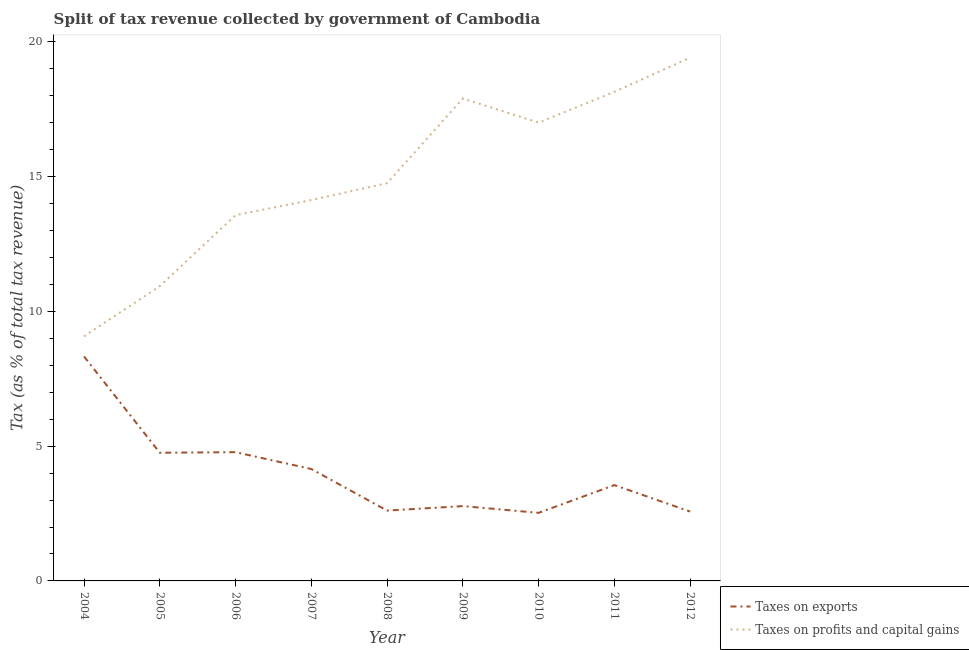How many different coloured lines are there?
Your answer should be compact. 2. Does the line corresponding to percentage of revenue obtained from taxes on profits and capital gains intersect with the line corresponding to percentage of revenue obtained from taxes on exports?
Offer a very short reply. No. What is the percentage of revenue obtained from taxes on profits and capital gains in 2007?
Your answer should be compact. 14.13. Across all years, what is the maximum percentage of revenue obtained from taxes on exports?
Make the answer very short. 8.33. Across all years, what is the minimum percentage of revenue obtained from taxes on profits and capital gains?
Give a very brief answer. 9.07. What is the total percentage of revenue obtained from taxes on profits and capital gains in the graph?
Offer a terse response. 134.96. What is the difference between the percentage of revenue obtained from taxes on profits and capital gains in 2011 and that in 2012?
Offer a very short reply. -1.27. What is the difference between the percentage of revenue obtained from taxes on exports in 2005 and the percentage of revenue obtained from taxes on profits and capital gains in 2012?
Offer a terse response. -14.66. What is the average percentage of revenue obtained from taxes on exports per year?
Give a very brief answer. 4.01. In the year 2010, what is the difference between the percentage of revenue obtained from taxes on exports and percentage of revenue obtained from taxes on profits and capital gains?
Offer a very short reply. -14.48. In how many years, is the percentage of revenue obtained from taxes on exports greater than 7 %?
Ensure brevity in your answer.  1. What is the ratio of the percentage of revenue obtained from taxes on exports in 2004 to that in 2011?
Your answer should be very brief. 2.34. Is the difference between the percentage of revenue obtained from taxes on profits and capital gains in 2009 and 2010 greater than the difference between the percentage of revenue obtained from taxes on exports in 2009 and 2010?
Ensure brevity in your answer.  Yes. What is the difference between the highest and the second highest percentage of revenue obtained from taxes on profits and capital gains?
Offer a terse response. 1.27. What is the difference between the highest and the lowest percentage of revenue obtained from taxes on profits and capital gains?
Make the answer very short. 10.34. In how many years, is the percentage of revenue obtained from taxes on profits and capital gains greater than the average percentage of revenue obtained from taxes on profits and capital gains taken over all years?
Ensure brevity in your answer.  4. Is the sum of the percentage of revenue obtained from taxes on profits and capital gains in 2005 and 2008 greater than the maximum percentage of revenue obtained from taxes on exports across all years?
Keep it short and to the point. Yes. Is the percentage of revenue obtained from taxes on profits and capital gains strictly greater than the percentage of revenue obtained from taxes on exports over the years?
Give a very brief answer. Yes. How many lines are there?
Give a very brief answer. 2. What is the difference between two consecutive major ticks on the Y-axis?
Keep it short and to the point. 5. Are the values on the major ticks of Y-axis written in scientific E-notation?
Keep it short and to the point. No. What is the title of the graph?
Your answer should be very brief. Split of tax revenue collected by government of Cambodia. Does "GDP at market prices" appear as one of the legend labels in the graph?
Give a very brief answer. No. What is the label or title of the X-axis?
Your answer should be very brief. Year. What is the label or title of the Y-axis?
Offer a terse response. Tax (as % of total tax revenue). What is the Tax (as % of total tax revenue) of Taxes on exports in 2004?
Your answer should be compact. 8.33. What is the Tax (as % of total tax revenue) of Taxes on profits and capital gains in 2004?
Your answer should be very brief. 9.07. What is the Tax (as % of total tax revenue) of Taxes on exports in 2005?
Offer a terse response. 4.76. What is the Tax (as % of total tax revenue) in Taxes on profits and capital gains in 2005?
Your answer should be very brief. 10.94. What is the Tax (as % of total tax revenue) in Taxes on exports in 2006?
Your answer should be very brief. 4.78. What is the Tax (as % of total tax revenue) in Taxes on profits and capital gains in 2006?
Offer a terse response. 13.57. What is the Tax (as % of total tax revenue) in Taxes on exports in 2007?
Give a very brief answer. 4.15. What is the Tax (as % of total tax revenue) in Taxes on profits and capital gains in 2007?
Your answer should be very brief. 14.13. What is the Tax (as % of total tax revenue) in Taxes on exports in 2008?
Your answer should be very brief. 2.61. What is the Tax (as % of total tax revenue) of Taxes on profits and capital gains in 2008?
Provide a short and direct response. 14.76. What is the Tax (as % of total tax revenue) in Taxes on exports in 2009?
Provide a short and direct response. 2.78. What is the Tax (as % of total tax revenue) of Taxes on profits and capital gains in 2009?
Offer a terse response. 17.9. What is the Tax (as % of total tax revenue) in Taxes on exports in 2010?
Provide a succinct answer. 2.53. What is the Tax (as % of total tax revenue) of Taxes on profits and capital gains in 2010?
Your answer should be compact. 17.01. What is the Tax (as % of total tax revenue) of Taxes on exports in 2011?
Provide a succinct answer. 3.56. What is the Tax (as % of total tax revenue) in Taxes on profits and capital gains in 2011?
Offer a very short reply. 18.15. What is the Tax (as % of total tax revenue) of Taxes on exports in 2012?
Your answer should be very brief. 2.57. What is the Tax (as % of total tax revenue) of Taxes on profits and capital gains in 2012?
Give a very brief answer. 19.42. Across all years, what is the maximum Tax (as % of total tax revenue) of Taxes on exports?
Offer a very short reply. 8.33. Across all years, what is the maximum Tax (as % of total tax revenue) in Taxes on profits and capital gains?
Make the answer very short. 19.42. Across all years, what is the minimum Tax (as % of total tax revenue) of Taxes on exports?
Give a very brief answer. 2.53. Across all years, what is the minimum Tax (as % of total tax revenue) of Taxes on profits and capital gains?
Give a very brief answer. 9.07. What is the total Tax (as % of total tax revenue) in Taxes on exports in the graph?
Keep it short and to the point. 36.06. What is the total Tax (as % of total tax revenue) of Taxes on profits and capital gains in the graph?
Give a very brief answer. 134.96. What is the difference between the Tax (as % of total tax revenue) of Taxes on exports in 2004 and that in 2005?
Provide a succinct answer. 3.57. What is the difference between the Tax (as % of total tax revenue) of Taxes on profits and capital gains in 2004 and that in 2005?
Ensure brevity in your answer.  -1.86. What is the difference between the Tax (as % of total tax revenue) in Taxes on exports in 2004 and that in 2006?
Offer a terse response. 3.55. What is the difference between the Tax (as % of total tax revenue) in Taxes on profits and capital gains in 2004 and that in 2006?
Make the answer very short. -4.5. What is the difference between the Tax (as % of total tax revenue) in Taxes on exports in 2004 and that in 2007?
Your response must be concise. 4.18. What is the difference between the Tax (as % of total tax revenue) in Taxes on profits and capital gains in 2004 and that in 2007?
Your response must be concise. -5.06. What is the difference between the Tax (as % of total tax revenue) of Taxes on exports in 2004 and that in 2008?
Give a very brief answer. 5.72. What is the difference between the Tax (as % of total tax revenue) of Taxes on profits and capital gains in 2004 and that in 2008?
Offer a terse response. -5.69. What is the difference between the Tax (as % of total tax revenue) in Taxes on exports in 2004 and that in 2009?
Give a very brief answer. 5.55. What is the difference between the Tax (as % of total tax revenue) of Taxes on profits and capital gains in 2004 and that in 2009?
Your response must be concise. -8.83. What is the difference between the Tax (as % of total tax revenue) in Taxes on exports in 2004 and that in 2010?
Your response must be concise. 5.8. What is the difference between the Tax (as % of total tax revenue) in Taxes on profits and capital gains in 2004 and that in 2010?
Give a very brief answer. -7.93. What is the difference between the Tax (as % of total tax revenue) in Taxes on exports in 2004 and that in 2011?
Your response must be concise. 4.77. What is the difference between the Tax (as % of total tax revenue) in Taxes on profits and capital gains in 2004 and that in 2011?
Your answer should be compact. -9.07. What is the difference between the Tax (as % of total tax revenue) in Taxes on exports in 2004 and that in 2012?
Provide a short and direct response. 5.76. What is the difference between the Tax (as % of total tax revenue) in Taxes on profits and capital gains in 2004 and that in 2012?
Ensure brevity in your answer.  -10.34. What is the difference between the Tax (as % of total tax revenue) in Taxes on exports in 2005 and that in 2006?
Your answer should be compact. -0.02. What is the difference between the Tax (as % of total tax revenue) of Taxes on profits and capital gains in 2005 and that in 2006?
Offer a terse response. -2.63. What is the difference between the Tax (as % of total tax revenue) of Taxes on exports in 2005 and that in 2007?
Give a very brief answer. 0.6. What is the difference between the Tax (as % of total tax revenue) of Taxes on profits and capital gains in 2005 and that in 2007?
Offer a terse response. -3.19. What is the difference between the Tax (as % of total tax revenue) of Taxes on exports in 2005 and that in 2008?
Provide a succinct answer. 2.15. What is the difference between the Tax (as % of total tax revenue) of Taxes on profits and capital gains in 2005 and that in 2008?
Provide a short and direct response. -3.82. What is the difference between the Tax (as % of total tax revenue) of Taxes on exports in 2005 and that in 2009?
Keep it short and to the point. 1.98. What is the difference between the Tax (as % of total tax revenue) in Taxes on profits and capital gains in 2005 and that in 2009?
Offer a very short reply. -6.96. What is the difference between the Tax (as % of total tax revenue) in Taxes on exports in 2005 and that in 2010?
Keep it short and to the point. 2.23. What is the difference between the Tax (as % of total tax revenue) in Taxes on profits and capital gains in 2005 and that in 2010?
Provide a succinct answer. -6.07. What is the difference between the Tax (as % of total tax revenue) in Taxes on exports in 2005 and that in 2011?
Ensure brevity in your answer.  1.2. What is the difference between the Tax (as % of total tax revenue) in Taxes on profits and capital gains in 2005 and that in 2011?
Your answer should be very brief. -7.21. What is the difference between the Tax (as % of total tax revenue) in Taxes on exports in 2005 and that in 2012?
Keep it short and to the point. 2.18. What is the difference between the Tax (as % of total tax revenue) of Taxes on profits and capital gains in 2005 and that in 2012?
Your response must be concise. -8.48. What is the difference between the Tax (as % of total tax revenue) of Taxes on exports in 2006 and that in 2007?
Offer a very short reply. 0.62. What is the difference between the Tax (as % of total tax revenue) in Taxes on profits and capital gains in 2006 and that in 2007?
Your answer should be very brief. -0.56. What is the difference between the Tax (as % of total tax revenue) of Taxes on exports in 2006 and that in 2008?
Give a very brief answer. 2.17. What is the difference between the Tax (as % of total tax revenue) in Taxes on profits and capital gains in 2006 and that in 2008?
Ensure brevity in your answer.  -1.19. What is the difference between the Tax (as % of total tax revenue) of Taxes on exports in 2006 and that in 2009?
Your response must be concise. 2. What is the difference between the Tax (as % of total tax revenue) of Taxes on profits and capital gains in 2006 and that in 2009?
Your response must be concise. -4.33. What is the difference between the Tax (as % of total tax revenue) in Taxes on exports in 2006 and that in 2010?
Offer a terse response. 2.25. What is the difference between the Tax (as % of total tax revenue) of Taxes on profits and capital gains in 2006 and that in 2010?
Your answer should be very brief. -3.43. What is the difference between the Tax (as % of total tax revenue) in Taxes on exports in 2006 and that in 2011?
Your answer should be compact. 1.22. What is the difference between the Tax (as % of total tax revenue) of Taxes on profits and capital gains in 2006 and that in 2011?
Make the answer very short. -4.58. What is the difference between the Tax (as % of total tax revenue) of Taxes on exports in 2006 and that in 2012?
Provide a short and direct response. 2.2. What is the difference between the Tax (as % of total tax revenue) of Taxes on profits and capital gains in 2006 and that in 2012?
Make the answer very short. -5.84. What is the difference between the Tax (as % of total tax revenue) of Taxes on exports in 2007 and that in 2008?
Provide a short and direct response. 1.54. What is the difference between the Tax (as % of total tax revenue) of Taxes on profits and capital gains in 2007 and that in 2008?
Make the answer very short. -0.63. What is the difference between the Tax (as % of total tax revenue) in Taxes on exports in 2007 and that in 2009?
Your answer should be very brief. 1.38. What is the difference between the Tax (as % of total tax revenue) in Taxes on profits and capital gains in 2007 and that in 2009?
Keep it short and to the point. -3.77. What is the difference between the Tax (as % of total tax revenue) of Taxes on exports in 2007 and that in 2010?
Offer a terse response. 1.63. What is the difference between the Tax (as % of total tax revenue) of Taxes on profits and capital gains in 2007 and that in 2010?
Your response must be concise. -2.87. What is the difference between the Tax (as % of total tax revenue) in Taxes on exports in 2007 and that in 2011?
Give a very brief answer. 0.6. What is the difference between the Tax (as % of total tax revenue) in Taxes on profits and capital gains in 2007 and that in 2011?
Provide a short and direct response. -4.02. What is the difference between the Tax (as % of total tax revenue) in Taxes on exports in 2007 and that in 2012?
Your answer should be very brief. 1.58. What is the difference between the Tax (as % of total tax revenue) of Taxes on profits and capital gains in 2007 and that in 2012?
Offer a terse response. -5.28. What is the difference between the Tax (as % of total tax revenue) of Taxes on exports in 2008 and that in 2009?
Offer a very short reply. -0.17. What is the difference between the Tax (as % of total tax revenue) in Taxes on profits and capital gains in 2008 and that in 2009?
Offer a very short reply. -3.14. What is the difference between the Tax (as % of total tax revenue) of Taxes on exports in 2008 and that in 2010?
Give a very brief answer. 0.08. What is the difference between the Tax (as % of total tax revenue) of Taxes on profits and capital gains in 2008 and that in 2010?
Offer a very short reply. -2.25. What is the difference between the Tax (as % of total tax revenue) in Taxes on exports in 2008 and that in 2011?
Your response must be concise. -0.95. What is the difference between the Tax (as % of total tax revenue) in Taxes on profits and capital gains in 2008 and that in 2011?
Ensure brevity in your answer.  -3.39. What is the difference between the Tax (as % of total tax revenue) in Taxes on exports in 2008 and that in 2012?
Offer a terse response. 0.04. What is the difference between the Tax (as % of total tax revenue) in Taxes on profits and capital gains in 2008 and that in 2012?
Ensure brevity in your answer.  -4.66. What is the difference between the Tax (as % of total tax revenue) of Taxes on exports in 2009 and that in 2010?
Offer a terse response. 0.25. What is the difference between the Tax (as % of total tax revenue) in Taxes on profits and capital gains in 2009 and that in 2010?
Ensure brevity in your answer.  0.9. What is the difference between the Tax (as % of total tax revenue) in Taxes on exports in 2009 and that in 2011?
Your answer should be very brief. -0.78. What is the difference between the Tax (as % of total tax revenue) in Taxes on profits and capital gains in 2009 and that in 2011?
Offer a terse response. -0.25. What is the difference between the Tax (as % of total tax revenue) of Taxes on exports in 2009 and that in 2012?
Keep it short and to the point. 0.2. What is the difference between the Tax (as % of total tax revenue) in Taxes on profits and capital gains in 2009 and that in 2012?
Provide a short and direct response. -1.52. What is the difference between the Tax (as % of total tax revenue) of Taxes on exports in 2010 and that in 2011?
Give a very brief answer. -1.03. What is the difference between the Tax (as % of total tax revenue) of Taxes on profits and capital gains in 2010 and that in 2011?
Ensure brevity in your answer.  -1.14. What is the difference between the Tax (as % of total tax revenue) of Taxes on exports in 2010 and that in 2012?
Ensure brevity in your answer.  -0.05. What is the difference between the Tax (as % of total tax revenue) of Taxes on profits and capital gains in 2010 and that in 2012?
Keep it short and to the point. -2.41. What is the difference between the Tax (as % of total tax revenue) of Taxes on exports in 2011 and that in 2012?
Provide a succinct answer. 0.98. What is the difference between the Tax (as % of total tax revenue) of Taxes on profits and capital gains in 2011 and that in 2012?
Provide a short and direct response. -1.27. What is the difference between the Tax (as % of total tax revenue) of Taxes on exports in 2004 and the Tax (as % of total tax revenue) of Taxes on profits and capital gains in 2005?
Your response must be concise. -2.61. What is the difference between the Tax (as % of total tax revenue) in Taxes on exports in 2004 and the Tax (as % of total tax revenue) in Taxes on profits and capital gains in 2006?
Offer a very short reply. -5.24. What is the difference between the Tax (as % of total tax revenue) of Taxes on exports in 2004 and the Tax (as % of total tax revenue) of Taxes on profits and capital gains in 2007?
Ensure brevity in your answer.  -5.81. What is the difference between the Tax (as % of total tax revenue) of Taxes on exports in 2004 and the Tax (as % of total tax revenue) of Taxes on profits and capital gains in 2008?
Ensure brevity in your answer.  -6.43. What is the difference between the Tax (as % of total tax revenue) in Taxes on exports in 2004 and the Tax (as % of total tax revenue) in Taxes on profits and capital gains in 2009?
Provide a short and direct response. -9.57. What is the difference between the Tax (as % of total tax revenue) in Taxes on exports in 2004 and the Tax (as % of total tax revenue) in Taxes on profits and capital gains in 2010?
Offer a terse response. -8.68. What is the difference between the Tax (as % of total tax revenue) in Taxes on exports in 2004 and the Tax (as % of total tax revenue) in Taxes on profits and capital gains in 2011?
Ensure brevity in your answer.  -9.82. What is the difference between the Tax (as % of total tax revenue) in Taxes on exports in 2004 and the Tax (as % of total tax revenue) in Taxes on profits and capital gains in 2012?
Ensure brevity in your answer.  -11.09. What is the difference between the Tax (as % of total tax revenue) in Taxes on exports in 2005 and the Tax (as % of total tax revenue) in Taxes on profits and capital gains in 2006?
Offer a very short reply. -8.82. What is the difference between the Tax (as % of total tax revenue) of Taxes on exports in 2005 and the Tax (as % of total tax revenue) of Taxes on profits and capital gains in 2007?
Provide a succinct answer. -9.38. What is the difference between the Tax (as % of total tax revenue) of Taxes on exports in 2005 and the Tax (as % of total tax revenue) of Taxes on profits and capital gains in 2008?
Provide a short and direct response. -10. What is the difference between the Tax (as % of total tax revenue) of Taxes on exports in 2005 and the Tax (as % of total tax revenue) of Taxes on profits and capital gains in 2009?
Your response must be concise. -13.15. What is the difference between the Tax (as % of total tax revenue) in Taxes on exports in 2005 and the Tax (as % of total tax revenue) in Taxes on profits and capital gains in 2010?
Ensure brevity in your answer.  -12.25. What is the difference between the Tax (as % of total tax revenue) of Taxes on exports in 2005 and the Tax (as % of total tax revenue) of Taxes on profits and capital gains in 2011?
Provide a short and direct response. -13.39. What is the difference between the Tax (as % of total tax revenue) in Taxes on exports in 2005 and the Tax (as % of total tax revenue) in Taxes on profits and capital gains in 2012?
Provide a short and direct response. -14.66. What is the difference between the Tax (as % of total tax revenue) of Taxes on exports in 2006 and the Tax (as % of total tax revenue) of Taxes on profits and capital gains in 2007?
Your answer should be compact. -9.36. What is the difference between the Tax (as % of total tax revenue) in Taxes on exports in 2006 and the Tax (as % of total tax revenue) in Taxes on profits and capital gains in 2008?
Offer a very short reply. -9.98. What is the difference between the Tax (as % of total tax revenue) of Taxes on exports in 2006 and the Tax (as % of total tax revenue) of Taxes on profits and capital gains in 2009?
Provide a succinct answer. -13.12. What is the difference between the Tax (as % of total tax revenue) of Taxes on exports in 2006 and the Tax (as % of total tax revenue) of Taxes on profits and capital gains in 2010?
Keep it short and to the point. -12.23. What is the difference between the Tax (as % of total tax revenue) in Taxes on exports in 2006 and the Tax (as % of total tax revenue) in Taxes on profits and capital gains in 2011?
Offer a terse response. -13.37. What is the difference between the Tax (as % of total tax revenue) of Taxes on exports in 2006 and the Tax (as % of total tax revenue) of Taxes on profits and capital gains in 2012?
Your answer should be compact. -14.64. What is the difference between the Tax (as % of total tax revenue) of Taxes on exports in 2007 and the Tax (as % of total tax revenue) of Taxes on profits and capital gains in 2008?
Your answer should be compact. -10.61. What is the difference between the Tax (as % of total tax revenue) of Taxes on exports in 2007 and the Tax (as % of total tax revenue) of Taxes on profits and capital gains in 2009?
Ensure brevity in your answer.  -13.75. What is the difference between the Tax (as % of total tax revenue) in Taxes on exports in 2007 and the Tax (as % of total tax revenue) in Taxes on profits and capital gains in 2010?
Keep it short and to the point. -12.85. What is the difference between the Tax (as % of total tax revenue) of Taxes on exports in 2007 and the Tax (as % of total tax revenue) of Taxes on profits and capital gains in 2011?
Your answer should be very brief. -14. What is the difference between the Tax (as % of total tax revenue) of Taxes on exports in 2007 and the Tax (as % of total tax revenue) of Taxes on profits and capital gains in 2012?
Your answer should be compact. -15.27. What is the difference between the Tax (as % of total tax revenue) of Taxes on exports in 2008 and the Tax (as % of total tax revenue) of Taxes on profits and capital gains in 2009?
Your answer should be compact. -15.29. What is the difference between the Tax (as % of total tax revenue) in Taxes on exports in 2008 and the Tax (as % of total tax revenue) in Taxes on profits and capital gains in 2010?
Your answer should be compact. -14.4. What is the difference between the Tax (as % of total tax revenue) of Taxes on exports in 2008 and the Tax (as % of total tax revenue) of Taxes on profits and capital gains in 2011?
Give a very brief answer. -15.54. What is the difference between the Tax (as % of total tax revenue) in Taxes on exports in 2008 and the Tax (as % of total tax revenue) in Taxes on profits and capital gains in 2012?
Make the answer very short. -16.81. What is the difference between the Tax (as % of total tax revenue) of Taxes on exports in 2009 and the Tax (as % of total tax revenue) of Taxes on profits and capital gains in 2010?
Offer a very short reply. -14.23. What is the difference between the Tax (as % of total tax revenue) in Taxes on exports in 2009 and the Tax (as % of total tax revenue) in Taxes on profits and capital gains in 2011?
Provide a short and direct response. -15.37. What is the difference between the Tax (as % of total tax revenue) in Taxes on exports in 2009 and the Tax (as % of total tax revenue) in Taxes on profits and capital gains in 2012?
Provide a short and direct response. -16.64. What is the difference between the Tax (as % of total tax revenue) in Taxes on exports in 2010 and the Tax (as % of total tax revenue) in Taxes on profits and capital gains in 2011?
Keep it short and to the point. -15.62. What is the difference between the Tax (as % of total tax revenue) in Taxes on exports in 2010 and the Tax (as % of total tax revenue) in Taxes on profits and capital gains in 2012?
Keep it short and to the point. -16.89. What is the difference between the Tax (as % of total tax revenue) of Taxes on exports in 2011 and the Tax (as % of total tax revenue) of Taxes on profits and capital gains in 2012?
Give a very brief answer. -15.86. What is the average Tax (as % of total tax revenue) of Taxes on exports per year?
Make the answer very short. 4.01. What is the average Tax (as % of total tax revenue) in Taxes on profits and capital gains per year?
Ensure brevity in your answer.  15. In the year 2004, what is the difference between the Tax (as % of total tax revenue) of Taxes on exports and Tax (as % of total tax revenue) of Taxes on profits and capital gains?
Ensure brevity in your answer.  -0.75. In the year 2005, what is the difference between the Tax (as % of total tax revenue) of Taxes on exports and Tax (as % of total tax revenue) of Taxes on profits and capital gains?
Ensure brevity in your answer.  -6.18. In the year 2006, what is the difference between the Tax (as % of total tax revenue) of Taxes on exports and Tax (as % of total tax revenue) of Taxes on profits and capital gains?
Your answer should be compact. -8.8. In the year 2007, what is the difference between the Tax (as % of total tax revenue) of Taxes on exports and Tax (as % of total tax revenue) of Taxes on profits and capital gains?
Give a very brief answer. -9.98. In the year 2008, what is the difference between the Tax (as % of total tax revenue) in Taxes on exports and Tax (as % of total tax revenue) in Taxes on profits and capital gains?
Your answer should be compact. -12.15. In the year 2009, what is the difference between the Tax (as % of total tax revenue) of Taxes on exports and Tax (as % of total tax revenue) of Taxes on profits and capital gains?
Your answer should be compact. -15.13. In the year 2010, what is the difference between the Tax (as % of total tax revenue) in Taxes on exports and Tax (as % of total tax revenue) in Taxes on profits and capital gains?
Ensure brevity in your answer.  -14.48. In the year 2011, what is the difference between the Tax (as % of total tax revenue) of Taxes on exports and Tax (as % of total tax revenue) of Taxes on profits and capital gains?
Give a very brief answer. -14.59. In the year 2012, what is the difference between the Tax (as % of total tax revenue) in Taxes on exports and Tax (as % of total tax revenue) in Taxes on profits and capital gains?
Offer a terse response. -16.85. What is the ratio of the Tax (as % of total tax revenue) in Taxes on exports in 2004 to that in 2005?
Your response must be concise. 1.75. What is the ratio of the Tax (as % of total tax revenue) of Taxes on profits and capital gains in 2004 to that in 2005?
Ensure brevity in your answer.  0.83. What is the ratio of the Tax (as % of total tax revenue) in Taxes on exports in 2004 to that in 2006?
Your answer should be very brief. 1.74. What is the ratio of the Tax (as % of total tax revenue) of Taxes on profits and capital gains in 2004 to that in 2006?
Offer a very short reply. 0.67. What is the ratio of the Tax (as % of total tax revenue) in Taxes on exports in 2004 to that in 2007?
Offer a very short reply. 2.01. What is the ratio of the Tax (as % of total tax revenue) in Taxes on profits and capital gains in 2004 to that in 2007?
Your answer should be compact. 0.64. What is the ratio of the Tax (as % of total tax revenue) in Taxes on exports in 2004 to that in 2008?
Your answer should be very brief. 3.19. What is the ratio of the Tax (as % of total tax revenue) in Taxes on profits and capital gains in 2004 to that in 2008?
Offer a very short reply. 0.61. What is the ratio of the Tax (as % of total tax revenue) in Taxes on exports in 2004 to that in 2009?
Make the answer very short. 3. What is the ratio of the Tax (as % of total tax revenue) in Taxes on profits and capital gains in 2004 to that in 2009?
Your answer should be very brief. 0.51. What is the ratio of the Tax (as % of total tax revenue) of Taxes on exports in 2004 to that in 2010?
Your answer should be very brief. 3.3. What is the ratio of the Tax (as % of total tax revenue) in Taxes on profits and capital gains in 2004 to that in 2010?
Give a very brief answer. 0.53. What is the ratio of the Tax (as % of total tax revenue) in Taxes on exports in 2004 to that in 2011?
Make the answer very short. 2.34. What is the ratio of the Tax (as % of total tax revenue) in Taxes on profits and capital gains in 2004 to that in 2011?
Your response must be concise. 0.5. What is the ratio of the Tax (as % of total tax revenue) of Taxes on exports in 2004 to that in 2012?
Keep it short and to the point. 3.24. What is the ratio of the Tax (as % of total tax revenue) of Taxes on profits and capital gains in 2004 to that in 2012?
Offer a very short reply. 0.47. What is the ratio of the Tax (as % of total tax revenue) of Taxes on profits and capital gains in 2005 to that in 2006?
Offer a very short reply. 0.81. What is the ratio of the Tax (as % of total tax revenue) in Taxes on exports in 2005 to that in 2007?
Provide a short and direct response. 1.15. What is the ratio of the Tax (as % of total tax revenue) in Taxes on profits and capital gains in 2005 to that in 2007?
Offer a very short reply. 0.77. What is the ratio of the Tax (as % of total tax revenue) in Taxes on exports in 2005 to that in 2008?
Keep it short and to the point. 1.82. What is the ratio of the Tax (as % of total tax revenue) in Taxes on profits and capital gains in 2005 to that in 2008?
Keep it short and to the point. 0.74. What is the ratio of the Tax (as % of total tax revenue) in Taxes on exports in 2005 to that in 2009?
Your answer should be compact. 1.71. What is the ratio of the Tax (as % of total tax revenue) in Taxes on profits and capital gains in 2005 to that in 2009?
Offer a terse response. 0.61. What is the ratio of the Tax (as % of total tax revenue) of Taxes on exports in 2005 to that in 2010?
Ensure brevity in your answer.  1.88. What is the ratio of the Tax (as % of total tax revenue) in Taxes on profits and capital gains in 2005 to that in 2010?
Your answer should be compact. 0.64. What is the ratio of the Tax (as % of total tax revenue) in Taxes on exports in 2005 to that in 2011?
Offer a very short reply. 1.34. What is the ratio of the Tax (as % of total tax revenue) of Taxes on profits and capital gains in 2005 to that in 2011?
Make the answer very short. 0.6. What is the ratio of the Tax (as % of total tax revenue) of Taxes on exports in 2005 to that in 2012?
Give a very brief answer. 1.85. What is the ratio of the Tax (as % of total tax revenue) of Taxes on profits and capital gains in 2005 to that in 2012?
Your answer should be very brief. 0.56. What is the ratio of the Tax (as % of total tax revenue) of Taxes on exports in 2006 to that in 2007?
Keep it short and to the point. 1.15. What is the ratio of the Tax (as % of total tax revenue) in Taxes on profits and capital gains in 2006 to that in 2007?
Keep it short and to the point. 0.96. What is the ratio of the Tax (as % of total tax revenue) in Taxes on exports in 2006 to that in 2008?
Provide a succinct answer. 1.83. What is the ratio of the Tax (as % of total tax revenue) in Taxes on profits and capital gains in 2006 to that in 2008?
Your answer should be very brief. 0.92. What is the ratio of the Tax (as % of total tax revenue) in Taxes on exports in 2006 to that in 2009?
Your answer should be very brief. 1.72. What is the ratio of the Tax (as % of total tax revenue) in Taxes on profits and capital gains in 2006 to that in 2009?
Provide a succinct answer. 0.76. What is the ratio of the Tax (as % of total tax revenue) in Taxes on exports in 2006 to that in 2010?
Your answer should be compact. 1.89. What is the ratio of the Tax (as % of total tax revenue) in Taxes on profits and capital gains in 2006 to that in 2010?
Ensure brevity in your answer.  0.8. What is the ratio of the Tax (as % of total tax revenue) of Taxes on exports in 2006 to that in 2011?
Give a very brief answer. 1.34. What is the ratio of the Tax (as % of total tax revenue) in Taxes on profits and capital gains in 2006 to that in 2011?
Provide a short and direct response. 0.75. What is the ratio of the Tax (as % of total tax revenue) of Taxes on exports in 2006 to that in 2012?
Your answer should be compact. 1.86. What is the ratio of the Tax (as % of total tax revenue) in Taxes on profits and capital gains in 2006 to that in 2012?
Offer a terse response. 0.7. What is the ratio of the Tax (as % of total tax revenue) of Taxes on exports in 2007 to that in 2008?
Your answer should be compact. 1.59. What is the ratio of the Tax (as % of total tax revenue) in Taxes on profits and capital gains in 2007 to that in 2008?
Keep it short and to the point. 0.96. What is the ratio of the Tax (as % of total tax revenue) of Taxes on exports in 2007 to that in 2009?
Offer a terse response. 1.5. What is the ratio of the Tax (as % of total tax revenue) of Taxes on profits and capital gains in 2007 to that in 2009?
Offer a very short reply. 0.79. What is the ratio of the Tax (as % of total tax revenue) of Taxes on exports in 2007 to that in 2010?
Keep it short and to the point. 1.64. What is the ratio of the Tax (as % of total tax revenue) in Taxes on profits and capital gains in 2007 to that in 2010?
Offer a very short reply. 0.83. What is the ratio of the Tax (as % of total tax revenue) in Taxes on exports in 2007 to that in 2011?
Give a very brief answer. 1.17. What is the ratio of the Tax (as % of total tax revenue) in Taxes on profits and capital gains in 2007 to that in 2011?
Your response must be concise. 0.78. What is the ratio of the Tax (as % of total tax revenue) of Taxes on exports in 2007 to that in 2012?
Offer a very short reply. 1.61. What is the ratio of the Tax (as % of total tax revenue) in Taxes on profits and capital gains in 2007 to that in 2012?
Your answer should be compact. 0.73. What is the ratio of the Tax (as % of total tax revenue) of Taxes on exports in 2008 to that in 2009?
Make the answer very short. 0.94. What is the ratio of the Tax (as % of total tax revenue) of Taxes on profits and capital gains in 2008 to that in 2009?
Offer a very short reply. 0.82. What is the ratio of the Tax (as % of total tax revenue) in Taxes on exports in 2008 to that in 2010?
Your answer should be compact. 1.03. What is the ratio of the Tax (as % of total tax revenue) in Taxes on profits and capital gains in 2008 to that in 2010?
Provide a short and direct response. 0.87. What is the ratio of the Tax (as % of total tax revenue) of Taxes on exports in 2008 to that in 2011?
Your answer should be compact. 0.73. What is the ratio of the Tax (as % of total tax revenue) of Taxes on profits and capital gains in 2008 to that in 2011?
Give a very brief answer. 0.81. What is the ratio of the Tax (as % of total tax revenue) of Taxes on exports in 2008 to that in 2012?
Your answer should be compact. 1.01. What is the ratio of the Tax (as % of total tax revenue) in Taxes on profits and capital gains in 2008 to that in 2012?
Provide a short and direct response. 0.76. What is the ratio of the Tax (as % of total tax revenue) of Taxes on exports in 2009 to that in 2010?
Your answer should be compact. 1.1. What is the ratio of the Tax (as % of total tax revenue) of Taxes on profits and capital gains in 2009 to that in 2010?
Your response must be concise. 1.05. What is the ratio of the Tax (as % of total tax revenue) in Taxes on exports in 2009 to that in 2011?
Give a very brief answer. 0.78. What is the ratio of the Tax (as % of total tax revenue) of Taxes on profits and capital gains in 2009 to that in 2011?
Give a very brief answer. 0.99. What is the ratio of the Tax (as % of total tax revenue) in Taxes on exports in 2009 to that in 2012?
Your response must be concise. 1.08. What is the ratio of the Tax (as % of total tax revenue) in Taxes on profits and capital gains in 2009 to that in 2012?
Offer a very short reply. 0.92. What is the ratio of the Tax (as % of total tax revenue) in Taxes on exports in 2010 to that in 2011?
Your answer should be compact. 0.71. What is the ratio of the Tax (as % of total tax revenue) in Taxes on profits and capital gains in 2010 to that in 2011?
Keep it short and to the point. 0.94. What is the ratio of the Tax (as % of total tax revenue) in Taxes on exports in 2010 to that in 2012?
Offer a very short reply. 0.98. What is the ratio of the Tax (as % of total tax revenue) in Taxes on profits and capital gains in 2010 to that in 2012?
Keep it short and to the point. 0.88. What is the ratio of the Tax (as % of total tax revenue) of Taxes on exports in 2011 to that in 2012?
Your answer should be very brief. 1.38. What is the ratio of the Tax (as % of total tax revenue) of Taxes on profits and capital gains in 2011 to that in 2012?
Offer a very short reply. 0.93. What is the difference between the highest and the second highest Tax (as % of total tax revenue) of Taxes on exports?
Give a very brief answer. 3.55. What is the difference between the highest and the second highest Tax (as % of total tax revenue) of Taxes on profits and capital gains?
Make the answer very short. 1.27. What is the difference between the highest and the lowest Tax (as % of total tax revenue) in Taxes on exports?
Your answer should be compact. 5.8. What is the difference between the highest and the lowest Tax (as % of total tax revenue) in Taxes on profits and capital gains?
Offer a terse response. 10.34. 